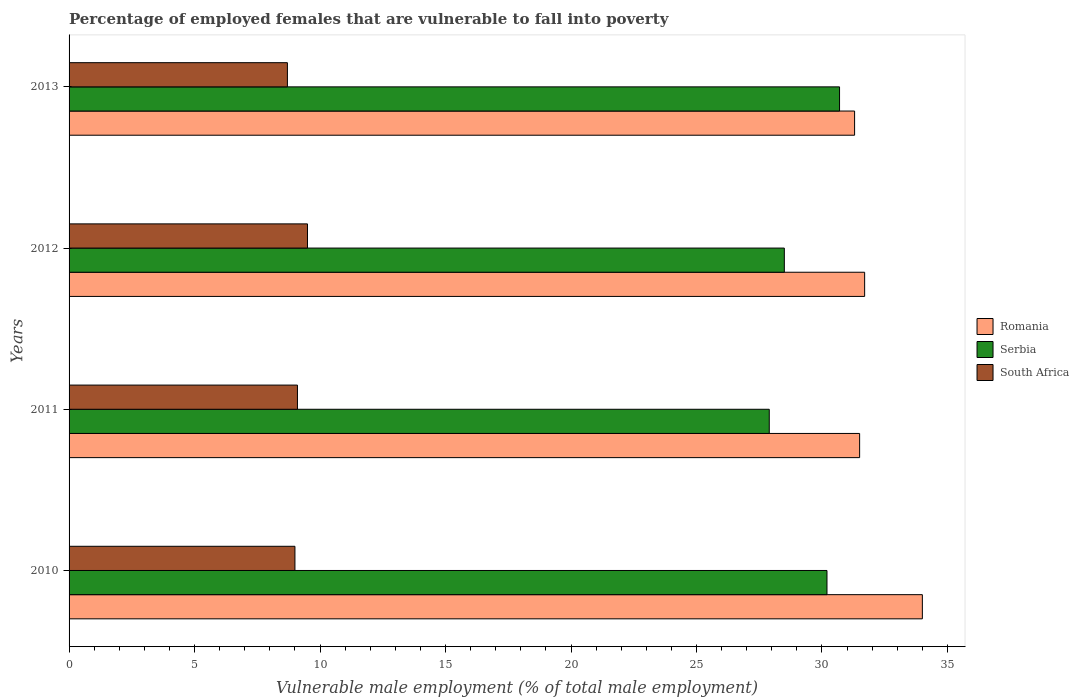Are the number of bars per tick equal to the number of legend labels?
Ensure brevity in your answer.  Yes. Are the number of bars on each tick of the Y-axis equal?
Your answer should be compact. Yes. How many bars are there on the 2nd tick from the bottom?
Your answer should be compact. 3. In how many cases, is the number of bars for a given year not equal to the number of legend labels?
Offer a very short reply. 0. Across all years, what is the maximum percentage of employed females who are vulnerable to fall into poverty in Serbia?
Keep it short and to the point. 30.7. Across all years, what is the minimum percentage of employed females who are vulnerable to fall into poverty in South Africa?
Offer a very short reply. 8.7. What is the total percentage of employed females who are vulnerable to fall into poverty in South Africa in the graph?
Your response must be concise. 36.3. What is the difference between the percentage of employed females who are vulnerable to fall into poverty in Serbia in 2010 and that in 2012?
Your answer should be very brief. 1.7. What is the difference between the percentage of employed females who are vulnerable to fall into poverty in South Africa in 2011 and the percentage of employed females who are vulnerable to fall into poverty in Serbia in 2012?
Give a very brief answer. -19.4. What is the average percentage of employed females who are vulnerable to fall into poverty in Serbia per year?
Give a very brief answer. 29.33. In the year 2011, what is the difference between the percentage of employed females who are vulnerable to fall into poverty in Serbia and percentage of employed females who are vulnerable to fall into poverty in Romania?
Ensure brevity in your answer.  -3.6. In how many years, is the percentage of employed females who are vulnerable to fall into poverty in Romania greater than 5 %?
Your response must be concise. 4. What is the ratio of the percentage of employed females who are vulnerable to fall into poverty in South Africa in 2011 to that in 2013?
Your response must be concise. 1.05. Is the difference between the percentage of employed females who are vulnerable to fall into poverty in Serbia in 2010 and 2013 greater than the difference between the percentage of employed females who are vulnerable to fall into poverty in Romania in 2010 and 2013?
Your answer should be very brief. No. What is the difference between the highest and the second highest percentage of employed females who are vulnerable to fall into poverty in Serbia?
Offer a terse response. 0.5. What is the difference between the highest and the lowest percentage of employed females who are vulnerable to fall into poverty in South Africa?
Offer a very short reply. 0.8. Is the sum of the percentage of employed females who are vulnerable to fall into poverty in Serbia in 2010 and 2011 greater than the maximum percentage of employed females who are vulnerable to fall into poverty in Romania across all years?
Offer a very short reply. Yes. What does the 1st bar from the top in 2013 represents?
Provide a short and direct response. South Africa. What does the 3rd bar from the bottom in 2010 represents?
Make the answer very short. South Africa. What is the difference between two consecutive major ticks on the X-axis?
Offer a terse response. 5. Does the graph contain any zero values?
Make the answer very short. No. Does the graph contain grids?
Give a very brief answer. No. Where does the legend appear in the graph?
Your answer should be very brief. Center right. How many legend labels are there?
Keep it short and to the point. 3. What is the title of the graph?
Give a very brief answer. Percentage of employed females that are vulnerable to fall into poverty. What is the label or title of the X-axis?
Your answer should be compact. Vulnerable male employment (% of total male employment). What is the label or title of the Y-axis?
Provide a succinct answer. Years. What is the Vulnerable male employment (% of total male employment) in Romania in 2010?
Provide a succinct answer. 34. What is the Vulnerable male employment (% of total male employment) of Serbia in 2010?
Your answer should be very brief. 30.2. What is the Vulnerable male employment (% of total male employment) of Romania in 2011?
Offer a terse response. 31.5. What is the Vulnerable male employment (% of total male employment) of Serbia in 2011?
Ensure brevity in your answer.  27.9. What is the Vulnerable male employment (% of total male employment) in South Africa in 2011?
Give a very brief answer. 9.1. What is the Vulnerable male employment (% of total male employment) in Romania in 2012?
Your answer should be compact. 31.7. What is the Vulnerable male employment (% of total male employment) in South Africa in 2012?
Give a very brief answer. 9.5. What is the Vulnerable male employment (% of total male employment) in Romania in 2013?
Provide a short and direct response. 31.3. What is the Vulnerable male employment (% of total male employment) of Serbia in 2013?
Make the answer very short. 30.7. What is the Vulnerable male employment (% of total male employment) in South Africa in 2013?
Ensure brevity in your answer.  8.7. Across all years, what is the maximum Vulnerable male employment (% of total male employment) of Romania?
Provide a succinct answer. 34. Across all years, what is the maximum Vulnerable male employment (% of total male employment) of Serbia?
Keep it short and to the point. 30.7. Across all years, what is the minimum Vulnerable male employment (% of total male employment) of Romania?
Make the answer very short. 31.3. Across all years, what is the minimum Vulnerable male employment (% of total male employment) of Serbia?
Offer a very short reply. 27.9. Across all years, what is the minimum Vulnerable male employment (% of total male employment) in South Africa?
Provide a succinct answer. 8.7. What is the total Vulnerable male employment (% of total male employment) of Romania in the graph?
Keep it short and to the point. 128.5. What is the total Vulnerable male employment (% of total male employment) in Serbia in the graph?
Offer a terse response. 117.3. What is the total Vulnerable male employment (% of total male employment) of South Africa in the graph?
Your response must be concise. 36.3. What is the difference between the Vulnerable male employment (% of total male employment) of South Africa in 2010 and that in 2011?
Make the answer very short. -0.1. What is the difference between the Vulnerable male employment (% of total male employment) of Romania in 2010 and that in 2012?
Provide a succinct answer. 2.3. What is the difference between the Vulnerable male employment (% of total male employment) of Serbia in 2010 and that in 2012?
Your response must be concise. 1.7. What is the difference between the Vulnerable male employment (% of total male employment) in Serbia in 2010 and that in 2013?
Offer a terse response. -0.5. What is the difference between the Vulnerable male employment (% of total male employment) of South Africa in 2010 and that in 2013?
Make the answer very short. 0.3. What is the difference between the Vulnerable male employment (% of total male employment) of Serbia in 2011 and that in 2012?
Provide a short and direct response. -0.6. What is the difference between the Vulnerable male employment (% of total male employment) in South Africa in 2011 and that in 2012?
Make the answer very short. -0.4. What is the difference between the Vulnerable male employment (% of total male employment) in Serbia in 2012 and that in 2013?
Provide a short and direct response. -2.2. What is the difference between the Vulnerable male employment (% of total male employment) of Romania in 2010 and the Vulnerable male employment (% of total male employment) of South Africa in 2011?
Provide a short and direct response. 24.9. What is the difference between the Vulnerable male employment (% of total male employment) in Serbia in 2010 and the Vulnerable male employment (% of total male employment) in South Africa in 2011?
Provide a short and direct response. 21.1. What is the difference between the Vulnerable male employment (% of total male employment) in Romania in 2010 and the Vulnerable male employment (% of total male employment) in Serbia in 2012?
Your answer should be compact. 5.5. What is the difference between the Vulnerable male employment (% of total male employment) of Serbia in 2010 and the Vulnerable male employment (% of total male employment) of South Africa in 2012?
Your response must be concise. 20.7. What is the difference between the Vulnerable male employment (% of total male employment) in Romania in 2010 and the Vulnerable male employment (% of total male employment) in South Africa in 2013?
Your response must be concise. 25.3. What is the difference between the Vulnerable male employment (% of total male employment) in Romania in 2011 and the Vulnerable male employment (% of total male employment) in South Africa in 2012?
Your response must be concise. 22. What is the difference between the Vulnerable male employment (% of total male employment) in Serbia in 2011 and the Vulnerable male employment (% of total male employment) in South Africa in 2012?
Your answer should be very brief. 18.4. What is the difference between the Vulnerable male employment (% of total male employment) in Romania in 2011 and the Vulnerable male employment (% of total male employment) in South Africa in 2013?
Your answer should be very brief. 22.8. What is the difference between the Vulnerable male employment (% of total male employment) in Serbia in 2012 and the Vulnerable male employment (% of total male employment) in South Africa in 2013?
Make the answer very short. 19.8. What is the average Vulnerable male employment (% of total male employment) in Romania per year?
Provide a succinct answer. 32.12. What is the average Vulnerable male employment (% of total male employment) in Serbia per year?
Offer a terse response. 29.32. What is the average Vulnerable male employment (% of total male employment) in South Africa per year?
Give a very brief answer. 9.07. In the year 2010, what is the difference between the Vulnerable male employment (% of total male employment) of Romania and Vulnerable male employment (% of total male employment) of Serbia?
Your answer should be very brief. 3.8. In the year 2010, what is the difference between the Vulnerable male employment (% of total male employment) in Serbia and Vulnerable male employment (% of total male employment) in South Africa?
Make the answer very short. 21.2. In the year 2011, what is the difference between the Vulnerable male employment (% of total male employment) of Romania and Vulnerable male employment (% of total male employment) of Serbia?
Your answer should be compact. 3.6. In the year 2011, what is the difference between the Vulnerable male employment (% of total male employment) of Romania and Vulnerable male employment (% of total male employment) of South Africa?
Ensure brevity in your answer.  22.4. In the year 2012, what is the difference between the Vulnerable male employment (% of total male employment) in Romania and Vulnerable male employment (% of total male employment) in Serbia?
Your answer should be compact. 3.2. In the year 2013, what is the difference between the Vulnerable male employment (% of total male employment) of Romania and Vulnerable male employment (% of total male employment) of South Africa?
Your response must be concise. 22.6. In the year 2013, what is the difference between the Vulnerable male employment (% of total male employment) in Serbia and Vulnerable male employment (% of total male employment) in South Africa?
Provide a short and direct response. 22. What is the ratio of the Vulnerable male employment (% of total male employment) in Romania in 2010 to that in 2011?
Provide a succinct answer. 1.08. What is the ratio of the Vulnerable male employment (% of total male employment) in Serbia in 2010 to that in 2011?
Give a very brief answer. 1.08. What is the ratio of the Vulnerable male employment (% of total male employment) of South Africa in 2010 to that in 2011?
Your response must be concise. 0.99. What is the ratio of the Vulnerable male employment (% of total male employment) of Romania in 2010 to that in 2012?
Provide a short and direct response. 1.07. What is the ratio of the Vulnerable male employment (% of total male employment) in Serbia in 2010 to that in 2012?
Make the answer very short. 1.06. What is the ratio of the Vulnerable male employment (% of total male employment) of South Africa in 2010 to that in 2012?
Give a very brief answer. 0.95. What is the ratio of the Vulnerable male employment (% of total male employment) in Romania in 2010 to that in 2013?
Your response must be concise. 1.09. What is the ratio of the Vulnerable male employment (% of total male employment) of Serbia in 2010 to that in 2013?
Your answer should be very brief. 0.98. What is the ratio of the Vulnerable male employment (% of total male employment) in South Africa in 2010 to that in 2013?
Your response must be concise. 1.03. What is the ratio of the Vulnerable male employment (% of total male employment) in Serbia in 2011 to that in 2012?
Ensure brevity in your answer.  0.98. What is the ratio of the Vulnerable male employment (% of total male employment) in South Africa in 2011 to that in 2012?
Ensure brevity in your answer.  0.96. What is the ratio of the Vulnerable male employment (% of total male employment) in Romania in 2011 to that in 2013?
Offer a terse response. 1.01. What is the ratio of the Vulnerable male employment (% of total male employment) of Serbia in 2011 to that in 2013?
Your response must be concise. 0.91. What is the ratio of the Vulnerable male employment (% of total male employment) of South Africa in 2011 to that in 2013?
Your answer should be very brief. 1.05. What is the ratio of the Vulnerable male employment (% of total male employment) in Romania in 2012 to that in 2013?
Give a very brief answer. 1.01. What is the ratio of the Vulnerable male employment (% of total male employment) in Serbia in 2012 to that in 2013?
Ensure brevity in your answer.  0.93. What is the ratio of the Vulnerable male employment (% of total male employment) of South Africa in 2012 to that in 2013?
Make the answer very short. 1.09. What is the difference between the highest and the second highest Vulnerable male employment (% of total male employment) in Serbia?
Provide a succinct answer. 0.5. What is the difference between the highest and the second highest Vulnerable male employment (% of total male employment) in South Africa?
Make the answer very short. 0.4. 